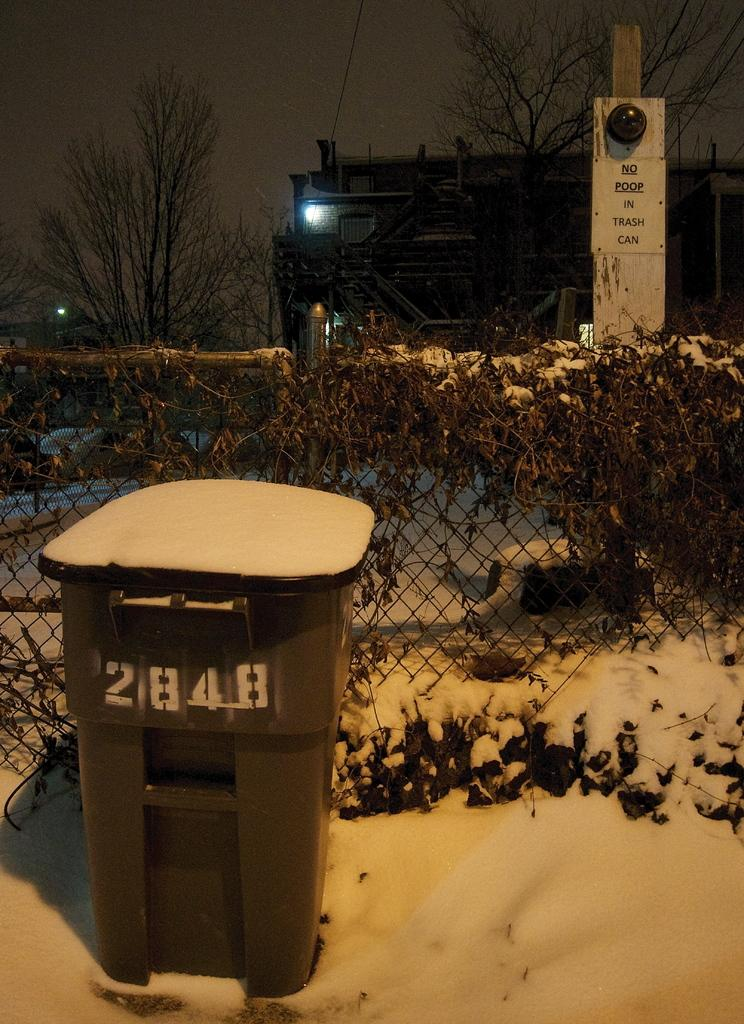<image>
Give a short and clear explanation of the subsequent image. A trash can labeled 2848 has snow on top of it. 